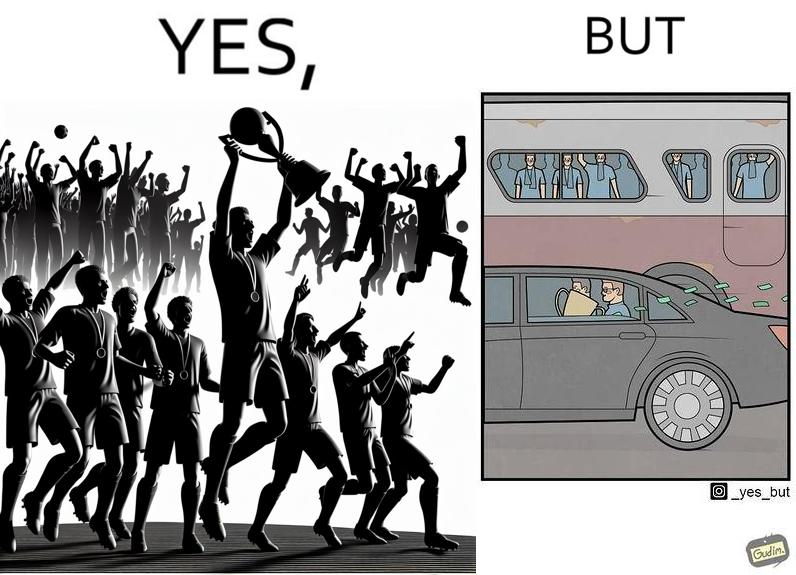Compare the left and right sides of this image. In the left part of the image: A football team has won some tournament, where the team with the cup are celebrating, along with their fans in the gallery. In the right part of the image: some people are standing in a bus, while some other people are travelling in a car carrying a cup, while cash notes are flowing out the car window. 